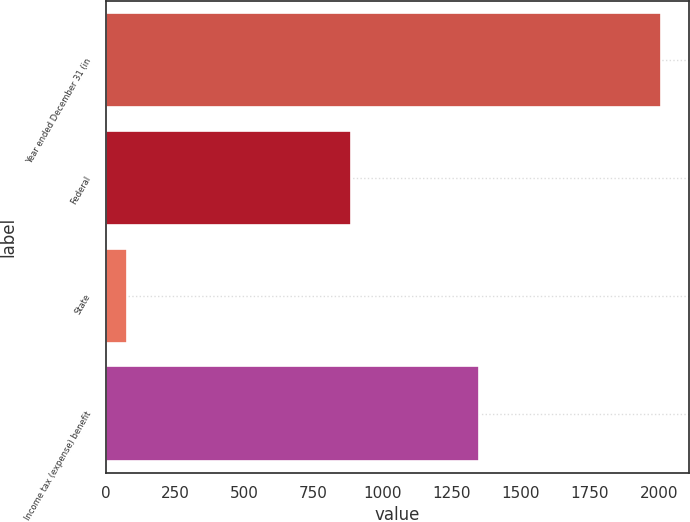Convert chart to OTSL. <chart><loc_0><loc_0><loc_500><loc_500><bar_chart><fcel>Year ended December 31 (in<fcel>Federal<fcel>State<fcel>Income tax (expense) benefit<nl><fcel>2006<fcel>887<fcel>77<fcel>1347<nl></chart> 